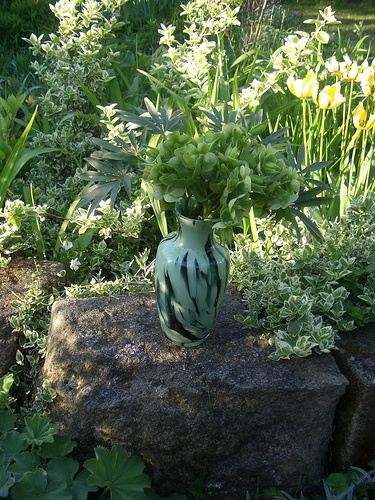Describe the objects in this image and their specific colors. I can see a vase in black and teal tones in this image. 